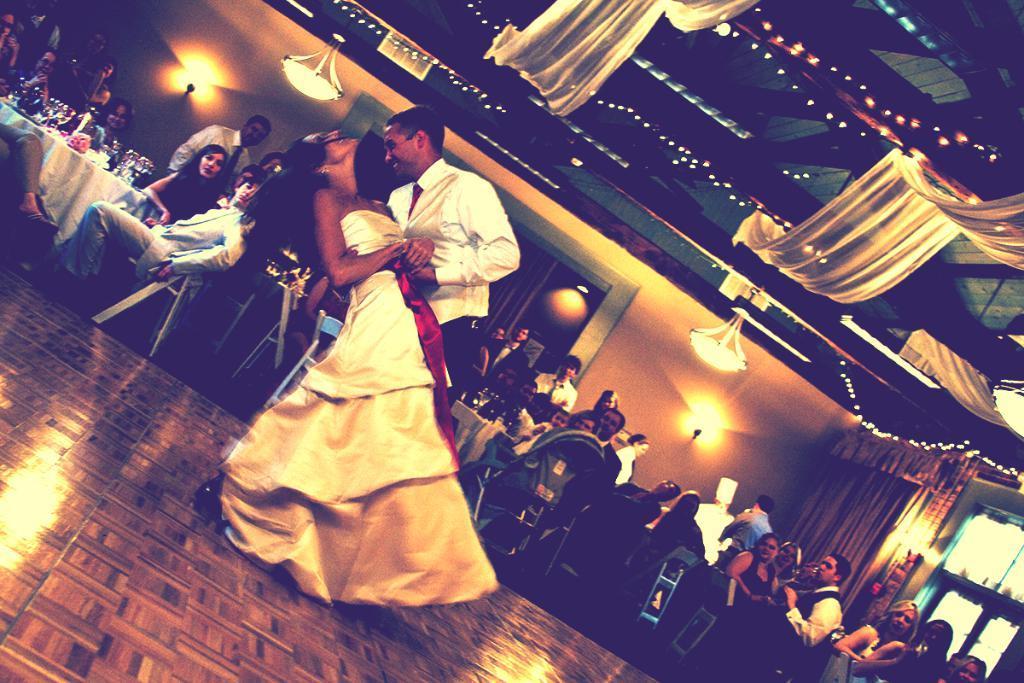Please provide a concise description of this image. In this picture, we see a man and a woman are performing on the stage. Behind them, we see the people are sitting on the chairs and they are watching the performance of the man and the woman. In front of them, we see a table on which alcohol bottles, glasses, flower vase and some other objects are placed. On the right side, we see the windows and a curtain. In the background, we see a wall and the lights. At the top, we see the lights and the roof of the building. 